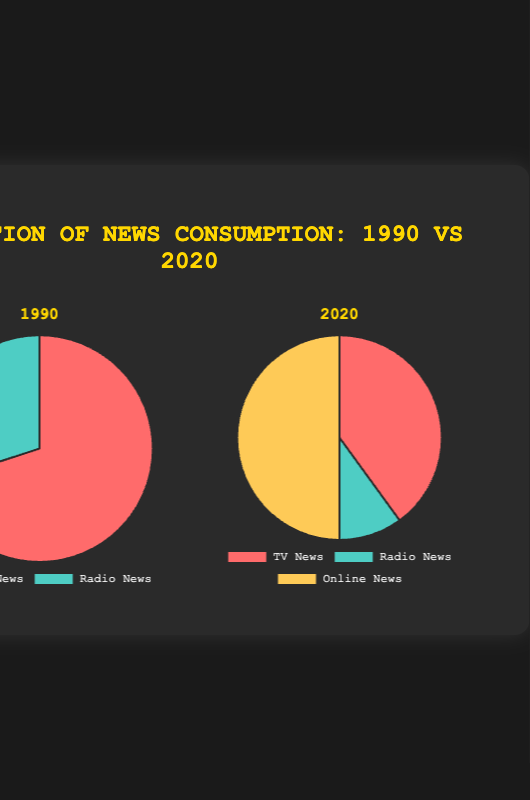How much higher was TV news consumption in 1990 compared to radio news consumption in 1990? TV news consumption in 1990 was 70%, and radio news consumption was 30%. The difference is 70% - 30% = 40%.
Answer: 40% What is the percentage share of online news consumption in 2020? Online news consumption in 2020 is represented as 50% in the pie chart.
Answer: 50% What is the total percentage of news consumption that is not TV news in 2020? In 2020, non-TV news consumption consists of radio news (10%) and online news (50%). The total is 10% + 50% = 60%.
Answer: 60% By how much did TV news consumption decrease from 1990 to 2020? TV news consumption in 1990 was 70%, and in 2020 it was 40%. The decrease is 70% - 40% = 30%.
Answer: 30% Which type of news consumption saw the greatest increase from 1990 to 2020? Online news consumption is the only new category added in 2020 and stands at 50%, making it the type with the greatest increase.
Answer: Online news consumption What type of news consumption had the greatest decline from 1990 to 2020? TV news consumption declined from 70% in 1990 to 40% in 2020, a decrease of 30%, which is the greatest decline observed.
Answer: TV news consumption What proportion of news consumption was represented by TV and radio combined in 1990? In 1990, TV news was 70% and radio news was 30%, which combined is 70% + 30% = 100%.
Answer: 100% Looking at the colors in the pie charts, which color represents radio news consumption in both 1990 and 2020? The color representing radio news consumption in both years is green.
Answer: Green What visual change is evident in the pie chart titles for 1990 and 2020? The title for each pie chart changes from "1990" to "2020", indicating the year the data is from.
Answer: Year change from 1990 to 2020 How much smaller is radio news consumption in 2020 compared to 1990? Radio news consumption in 1990 was 30%, and in 2020, it is 10%. The decrease is 30% - 10% = 20%.
Answer: 20% 